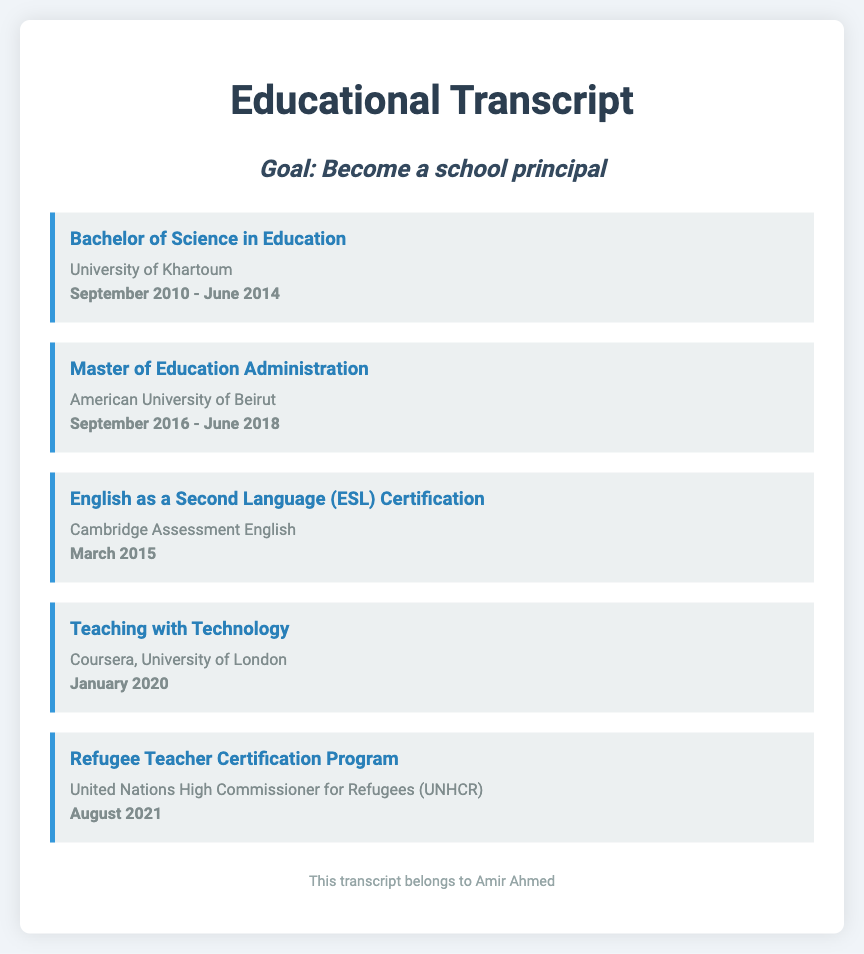what degree did Amir Ahmed earn first? Amir Ahmed first earned a Bachelor of Science in Education, as listed in the document.
Answer: Bachelor of Science in Education which university did Amir Ahmed attend for his master's degree? The document states that Amir Ahmed attended the American University of Beirut for his master's degree in Education Administration.
Answer: American University of Beirut when did Amir Ahmed receive his ESL certification? The document specifies that Amir Ahmed received his ESL certification in March 2015.
Answer: March 2015 what certification did Amir Ahmed obtain in August 2021? The document indicates that Amir Ahmed obtained the Refugee Teacher Certification Program in August 2021.
Answer: Refugee Teacher Certification Program how many educational achievements are listed in the transcript? There are five educational achievements listed in the transcript, as per the provided document structure.
Answer: Five which organization awarded the Refugee Teacher Certification? The document mentions that the Refugee Teacher Certification Program was awarded by the United Nations High Commissioner for Refugees (UNHCR).
Answer: United Nations High Commissioner for Refugees (UNHCR) what is Amir Ahmed's ultimate career goal? The document explicitly states Amir Ahmed's goal is to become a school principal.
Answer: Become a school principal in what year did Amir Ahmed complete his bachelor's degree? According to the document, Amir Ahmed completed his bachelor's degree in June 2014.
Answer: June 2014 what course did Amir Ahmed take from Coursera? The document lists that Amir Ahmed took a course titled Teaching with Technology from Coursera, University of London.
Answer: Teaching with Technology 